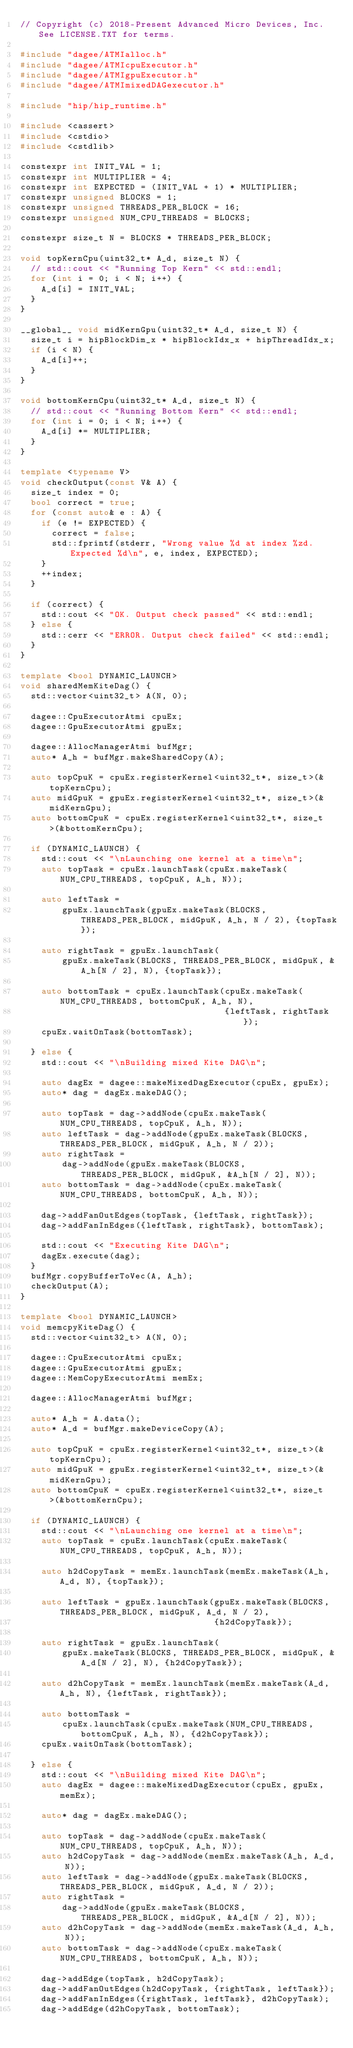<code> <loc_0><loc_0><loc_500><loc_500><_C++_>// Copyright (c) 2018-Present Advanced Micro Devices, Inc. See LICENSE.TXT for terms.

#include "dagee/ATMIalloc.h"
#include "dagee/ATMIcpuExecutor.h"
#include "dagee/ATMIgpuExecutor.h"
#include "dagee/ATMImixedDAGexecutor.h"

#include "hip/hip_runtime.h"

#include <cassert>
#include <cstdio>
#include <cstdlib>

constexpr int INIT_VAL = 1;
constexpr int MULTIPLIER = 4;
constexpr int EXPECTED = (INIT_VAL + 1) * MULTIPLIER;
constexpr unsigned BLOCKS = 1;
constexpr unsigned THREADS_PER_BLOCK = 16;
constexpr unsigned NUM_CPU_THREADS = BLOCKS;

constexpr size_t N = BLOCKS * THREADS_PER_BLOCK;

void topKernCpu(uint32_t* A_d, size_t N) {
  // std::cout << "Running Top Kern" << std::endl;
  for (int i = 0; i < N; i++) {
    A_d[i] = INIT_VAL;
  }
}

__global__ void midKernGpu(uint32_t* A_d, size_t N) {
  size_t i = hipBlockDim_x * hipBlockIdx_x + hipThreadIdx_x;
  if (i < N) {
    A_d[i]++;
  }
}

void bottomKernCpu(uint32_t* A_d, size_t N) {
  // std::cout << "Running Bottom Kern" << std::endl;
  for (int i = 0; i < N; i++) {
    A_d[i] *= MULTIPLIER;
  }
}

template <typename V>
void checkOutput(const V& A) {
  size_t index = 0;
  bool correct = true;
  for (const auto& e : A) {
    if (e != EXPECTED) {
      correct = false;
      std::fprintf(stderr, "Wrong value %d at index %zd. Expected %d\n", e, index, EXPECTED);
    }
    ++index;
  }

  if (correct) {
    std::cout << "OK. Output check passed" << std::endl;
  } else {
    std::cerr << "ERROR. Output check failed" << std::endl;
  }
}

template <bool DYNAMIC_LAUNCH>
void sharedMemKiteDag() {
  std::vector<uint32_t> A(N, 0);

  dagee::CpuExecutorAtmi cpuEx;
  dagee::GpuExecutorAtmi gpuEx;

  dagee::AllocManagerAtmi bufMgr;
  auto* A_h = bufMgr.makeSharedCopy(A);

  auto topCpuK = cpuEx.registerKernel<uint32_t*, size_t>(&topKernCpu);
  auto midGpuK = gpuEx.registerKernel<uint32_t*, size_t>(&midKernGpu);
  auto bottomCpuK = cpuEx.registerKernel<uint32_t*, size_t>(&bottomKernCpu);

  if (DYNAMIC_LAUNCH) {
    std::cout << "\nLaunching one kernel at a time\n";
    auto topTask = cpuEx.launchTask(cpuEx.makeTask(NUM_CPU_THREADS, topCpuK, A_h, N));

    auto leftTask =
        gpuEx.launchTask(gpuEx.makeTask(BLOCKS, THREADS_PER_BLOCK, midGpuK, A_h, N / 2), {topTask});

    auto rightTask = gpuEx.launchTask(
        gpuEx.makeTask(BLOCKS, THREADS_PER_BLOCK, midGpuK, &A_h[N / 2], N), {topTask});

    auto bottomTask = cpuEx.launchTask(cpuEx.makeTask(NUM_CPU_THREADS, bottomCpuK, A_h, N),
                                       {leftTask, rightTask});
    cpuEx.waitOnTask(bottomTask);

  } else {
    std::cout << "\nBuilding mixed Kite DAG\n";

    auto dagEx = dagee::makeMixedDagExecutor(cpuEx, gpuEx);
    auto* dag = dagEx.makeDAG();

    auto topTask = dag->addNode(cpuEx.makeTask(NUM_CPU_THREADS, topCpuK, A_h, N));
    auto leftTask = dag->addNode(gpuEx.makeTask(BLOCKS, THREADS_PER_BLOCK, midGpuK, A_h, N / 2));
    auto rightTask =
        dag->addNode(gpuEx.makeTask(BLOCKS, THREADS_PER_BLOCK, midGpuK, &A_h[N / 2], N));
    auto bottomTask = dag->addNode(cpuEx.makeTask(NUM_CPU_THREADS, bottomCpuK, A_h, N));

    dag->addFanOutEdges(topTask, {leftTask, rightTask});
    dag->addFanInEdges({leftTask, rightTask}, bottomTask);

    std::cout << "Executing Kite DAG\n";
    dagEx.execute(dag);
  }
  bufMgr.copyBufferToVec(A, A_h);
  checkOutput(A);
}

template <bool DYNAMIC_LAUNCH>
void memcpyKiteDag() {
  std::vector<uint32_t> A(N, 0);

  dagee::CpuExecutorAtmi cpuEx;
  dagee::GpuExecutorAtmi gpuEx;
  dagee::MemCopyExecutorAtmi memEx;

  dagee::AllocManagerAtmi bufMgr;

  auto* A_h = A.data();
  auto* A_d = bufMgr.makeDeviceCopy(A);

  auto topCpuK = cpuEx.registerKernel<uint32_t*, size_t>(&topKernCpu);
  auto midGpuK = gpuEx.registerKernel<uint32_t*, size_t>(&midKernGpu);
  auto bottomCpuK = cpuEx.registerKernel<uint32_t*, size_t>(&bottomKernCpu);

  if (DYNAMIC_LAUNCH) {
    std::cout << "\nLaunching one kernel at a time\n";
    auto topTask = cpuEx.launchTask(cpuEx.makeTask(NUM_CPU_THREADS, topCpuK, A_h, N));

    auto h2dCopyTask = memEx.launchTask(memEx.makeTask(A_h, A_d, N), {topTask});

    auto leftTask = gpuEx.launchTask(gpuEx.makeTask(BLOCKS, THREADS_PER_BLOCK, midGpuK, A_d, N / 2),
                                     {h2dCopyTask});

    auto rightTask = gpuEx.launchTask(
        gpuEx.makeTask(BLOCKS, THREADS_PER_BLOCK, midGpuK, &A_d[N / 2], N), {h2dCopyTask});

    auto d2hCopyTask = memEx.launchTask(memEx.makeTask(A_d, A_h, N), {leftTask, rightTask});

    auto bottomTask =
        cpuEx.launchTask(cpuEx.makeTask(NUM_CPU_THREADS, bottomCpuK, A_h, N), {d2hCopyTask});
    cpuEx.waitOnTask(bottomTask);

  } else {
    std::cout << "\nBuilding mixed Kite DAG\n";
    auto dagEx = dagee::makeMixedDagExecutor(cpuEx, gpuEx, memEx);

    auto* dag = dagEx.makeDAG();

    auto topTask = dag->addNode(cpuEx.makeTask(NUM_CPU_THREADS, topCpuK, A_h, N));
    auto h2dCopyTask = dag->addNode(memEx.makeTask(A_h, A_d, N));
    auto leftTask = dag->addNode(gpuEx.makeTask(BLOCKS, THREADS_PER_BLOCK, midGpuK, A_d, N / 2));
    auto rightTask =
        dag->addNode(gpuEx.makeTask(BLOCKS, THREADS_PER_BLOCK, midGpuK, &A_d[N / 2], N));
    auto d2hCopyTask = dag->addNode(memEx.makeTask(A_d, A_h, N));
    auto bottomTask = dag->addNode(cpuEx.makeTask(NUM_CPU_THREADS, bottomCpuK, A_h, N));

    dag->addEdge(topTask, h2dCopyTask);
    dag->addFanOutEdges(h2dCopyTask, {rightTask, leftTask});
    dag->addFanInEdges({rightTask, leftTask}, d2hCopyTask);
    dag->addEdge(d2hCopyTask, bottomTask);</code> 